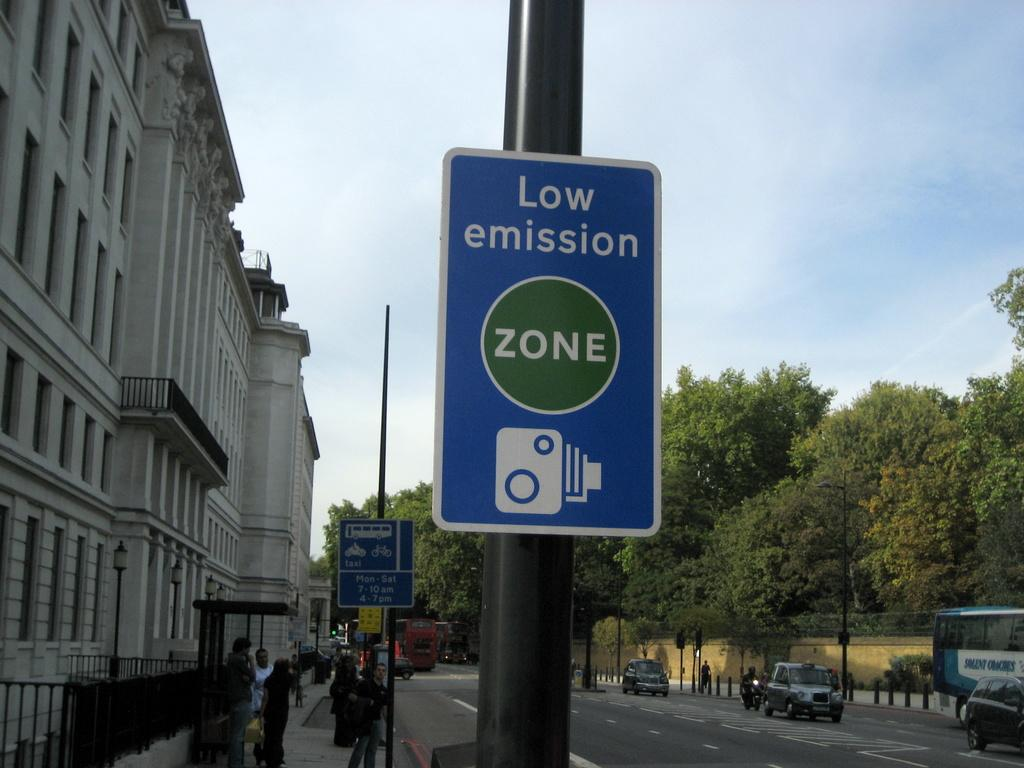<image>
Present a compact description of the photo's key features. A blue sign on a street that says Low emission zone 